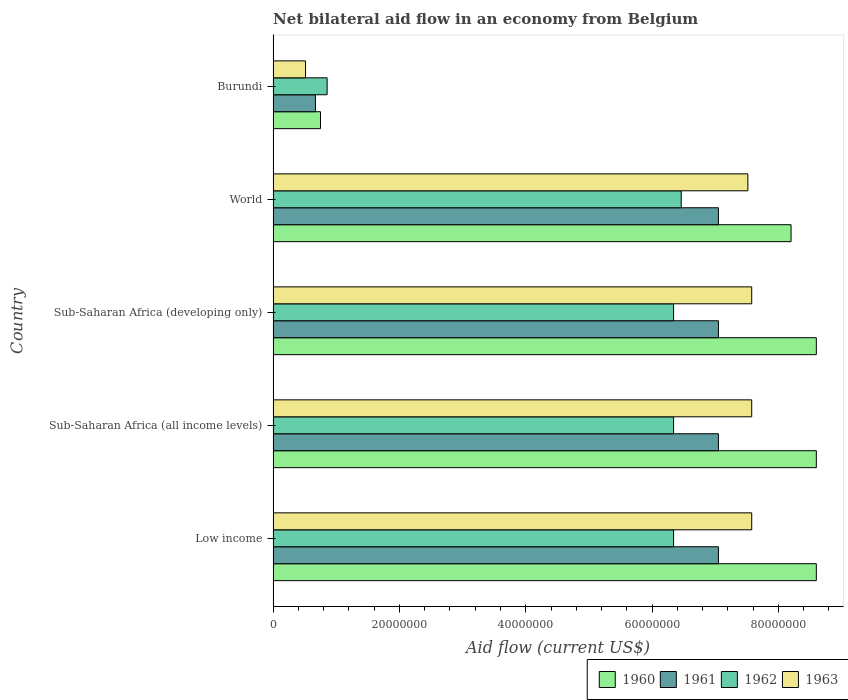How many different coloured bars are there?
Your response must be concise. 4. How many groups of bars are there?
Provide a succinct answer. 5. Are the number of bars per tick equal to the number of legend labels?
Your answer should be compact. Yes. Are the number of bars on each tick of the Y-axis equal?
Offer a very short reply. Yes. In how many cases, is the number of bars for a given country not equal to the number of legend labels?
Make the answer very short. 0. What is the net bilateral aid flow in 1961 in Sub-Saharan Africa (developing only)?
Your answer should be very brief. 7.05e+07. Across all countries, what is the maximum net bilateral aid flow in 1962?
Your response must be concise. 6.46e+07. Across all countries, what is the minimum net bilateral aid flow in 1962?
Your response must be concise. 8.55e+06. In which country was the net bilateral aid flow in 1962 maximum?
Your response must be concise. World. In which country was the net bilateral aid flow in 1962 minimum?
Keep it short and to the point. Burundi. What is the total net bilateral aid flow in 1963 in the graph?
Offer a very short reply. 3.08e+08. What is the difference between the net bilateral aid flow in 1960 in Sub-Saharan Africa (developing only) and that in World?
Your response must be concise. 4.00e+06. What is the difference between the net bilateral aid flow in 1960 in Sub-Saharan Africa (developing only) and the net bilateral aid flow in 1961 in Low income?
Make the answer very short. 1.55e+07. What is the average net bilateral aid flow in 1962 per country?
Provide a succinct answer. 5.27e+07. What is the difference between the net bilateral aid flow in 1962 and net bilateral aid flow in 1960 in Sub-Saharan Africa (developing only)?
Provide a succinct answer. -2.26e+07. In how many countries, is the net bilateral aid flow in 1961 greater than 84000000 US$?
Your answer should be very brief. 0. What is the ratio of the net bilateral aid flow in 1961 in Sub-Saharan Africa (all income levels) to that in World?
Offer a terse response. 1. Is the difference between the net bilateral aid flow in 1962 in Burundi and Low income greater than the difference between the net bilateral aid flow in 1960 in Burundi and Low income?
Give a very brief answer. Yes. What is the difference between the highest and the second highest net bilateral aid flow in 1960?
Your response must be concise. 0. What is the difference between the highest and the lowest net bilateral aid flow in 1963?
Your answer should be compact. 7.06e+07. In how many countries, is the net bilateral aid flow in 1960 greater than the average net bilateral aid flow in 1960 taken over all countries?
Your response must be concise. 4. Is it the case that in every country, the sum of the net bilateral aid flow in 1962 and net bilateral aid flow in 1960 is greater than the sum of net bilateral aid flow in 1961 and net bilateral aid flow in 1963?
Ensure brevity in your answer.  No. What does the 3rd bar from the top in Low income represents?
Your response must be concise. 1961. What does the 1st bar from the bottom in World represents?
Make the answer very short. 1960. How many bars are there?
Your answer should be compact. 20. How many countries are there in the graph?
Your response must be concise. 5. Are the values on the major ticks of X-axis written in scientific E-notation?
Ensure brevity in your answer.  No. Does the graph contain grids?
Ensure brevity in your answer.  No. How many legend labels are there?
Offer a very short reply. 4. How are the legend labels stacked?
Keep it short and to the point. Horizontal. What is the title of the graph?
Offer a very short reply. Net bilateral aid flow in an economy from Belgium. Does "1981" appear as one of the legend labels in the graph?
Your response must be concise. No. What is the Aid flow (current US$) of 1960 in Low income?
Offer a terse response. 8.60e+07. What is the Aid flow (current US$) in 1961 in Low income?
Offer a terse response. 7.05e+07. What is the Aid flow (current US$) of 1962 in Low income?
Offer a very short reply. 6.34e+07. What is the Aid flow (current US$) of 1963 in Low income?
Your response must be concise. 7.58e+07. What is the Aid flow (current US$) in 1960 in Sub-Saharan Africa (all income levels)?
Your answer should be very brief. 8.60e+07. What is the Aid flow (current US$) in 1961 in Sub-Saharan Africa (all income levels)?
Offer a very short reply. 7.05e+07. What is the Aid flow (current US$) in 1962 in Sub-Saharan Africa (all income levels)?
Provide a short and direct response. 6.34e+07. What is the Aid flow (current US$) of 1963 in Sub-Saharan Africa (all income levels)?
Offer a terse response. 7.58e+07. What is the Aid flow (current US$) in 1960 in Sub-Saharan Africa (developing only)?
Provide a succinct answer. 8.60e+07. What is the Aid flow (current US$) of 1961 in Sub-Saharan Africa (developing only)?
Keep it short and to the point. 7.05e+07. What is the Aid flow (current US$) of 1962 in Sub-Saharan Africa (developing only)?
Provide a succinct answer. 6.34e+07. What is the Aid flow (current US$) of 1963 in Sub-Saharan Africa (developing only)?
Make the answer very short. 7.58e+07. What is the Aid flow (current US$) of 1960 in World?
Make the answer very short. 8.20e+07. What is the Aid flow (current US$) in 1961 in World?
Offer a terse response. 7.05e+07. What is the Aid flow (current US$) of 1962 in World?
Your answer should be very brief. 6.46e+07. What is the Aid flow (current US$) in 1963 in World?
Offer a very short reply. 7.52e+07. What is the Aid flow (current US$) in 1960 in Burundi?
Provide a short and direct response. 7.50e+06. What is the Aid flow (current US$) in 1961 in Burundi?
Your response must be concise. 6.70e+06. What is the Aid flow (current US$) of 1962 in Burundi?
Offer a terse response. 8.55e+06. What is the Aid flow (current US$) in 1963 in Burundi?
Offer a very short reply. 5.13e+06. Across all countries, what is the maximum Aid flow (current US$) of 1960?
Provide a succinct answer. 8.60e+07. Across all countries, what is the maximum Aid flow (current US$) in 1961?
Your answer should be compact. 7.05e+07. Across all countries, what is the maximum Aid flow (current US$) of 1962?
Ensure brevity in your answer.  6.46e+07. Across all countries, what is the maximum Aid flow (current US$) in 1963?
Provide a succinct answer. 7.58e+07. Across all countries, what is the minimum Aid flow (current US$) of 1960?
Offer a very short reply. 7.50e+06. Across all countries, what is the minimum Aid flow (current US$) in 1961?
Keep it short and to the point. 6.70e+06. Across all countries, what is the minimum Aid flow (current US$) in 1962?
Provide a succinct answer. 8.55e+06. Across all countries, what is the minimum Aid flow (current US$) of 1963?
Give a very brief answer. 5.13e+06. What is the total Aid flow (current US$) of 1960 in the graph?
Offer a very short reply. 3.48e+08. What is the total Aid flow (current US$) in 1961 in the graph?
Provide a succinct answer. 2.89e+08. What is the total Aid flow (current US$) of 1962 in the graph?
Give a very brief answer. 2.63e+08. What is the total Aid flow (current US$) in 1963 in the graph?
Provide a succinct answer. 3.08e+08. What is the difference between the Aid flow (current US$) of 1961 in Low income and that in Sub-Saharan Africa (developing only)?
Offer a very short reply. 0. What is the difference between the Aid flow (current US$) of 1960 in Low income and that in World?
Offer a very short reply. 4.00e+06. What is the difference between the Aid flow (current US$) in 1962 in Low income and that in World?
Make the answer very short. -1.21e+06. What is the difference between the Aid flow (current US$) of 1963 in Low income and that in World?
Ensure brevity in your answer.  6.10e+05. What is the difference between the Aid flow (current US$) in 1960 in Low income and that in Burundi?
Keep it short and to the point. 7.85e+07. What is the difference between the Aid flow (current US$) of 1961 in Low income and that in Burundi?
Your answer should be very brief. 6.38e+07. What is the difference between the Aid flow (current US$) of 1962 in Low income and that in Burundi?
Offer a terse response. 5.48e+07. What is the difference between the Aid flow (current US$) in 1963 in Low income and that in Burundi?
Ensure brevity in your answer.  7.06e+07. What is the difference between the Aid flow (current US$) in 1961 in Sub-Saharan Africa (all income levels) and that in Sub-Saharan Africa (developing only)?
Make the answer very short. 0. What is the difference between the Aid flow (current US$) in 1962 in Sub-Saharan Africa (all income levels) and that in Sub-Saharan Africa (developing only)?
Provide a short and direct response. 0. What is the difference between the Aid flow (current US$) of 1963 in Sub-Saharan Africa (all income levels) and that in Sub-Saharan Africa (developing only)?
Make the answer very short. 0. What is the difference between the Aid flow (current US$) of 1960 in Sub-Saharan Africa (all income levels) and that in World?
Provide a short and direct response. 4.00e+06. What is the difference between the Aid flow (current US$) of 1961 in Sub-Saharan Africa (all income levels) and that in World?
Give a very brief answer. 0. What is the difference between the Aid flow (current US$) of 1962 in Sub-Saharan Africa (all income levels) and that in World?
Give a very brief answer. -1.21e+06. What is the difference between the Aid flow (current US$) in 1963 in Sub-Saharan Africa (all income levels) and that in World?
Offer a very short reply. 6.10e+05. What is the difference between the Aid flow (current US$) of 1960 in Sub-Saharan Africa (all income levels) and that in Burundi?
Your answer should be compact. 7.85e+07. What is the difference between the Aid flow (current US$) of 1961 in Sub-Saharan Africa (all income levels) and that in Burundi?
Offer a terse response. 6.38e+07. What is the difference between the Aid flow (current US$) in 1962 in Sub-Saharan Africa (all income levels) and that in Burundi?
Provide a short and direct response. 5.48e+07. What is the difference between the Aid flow (current US$) of 1963 in Sub-Saharan Africa (all income levels) and that in Burundi?
Give a very brief answer. 7.06e+07. What is the difference between the Aid flow (current US$) of 1962 in Sub-Saharan Africa (developing only) and that in World?
Provide a succinct answer. -1.21e+06. What is the difference between the Aid flow (current US$) in 1960 in Sub-Saharan Africa (developing only) and that in Burundi?
Make the answer very short. 7.85e+07. What is the difference between the Aid flow (current US$) of 1961 in Sub-Saharan Africa (developing only) and that in Burundi?
Ensure brevity in your answer.  6.38e+07. What is the difference between the Aid flow (current US$) of 1962 in Sub-Saharan Africa (developing only) and that in Burundi?
Ensure brevity in your answer.  5.48e+07. What is the difference between the Aid flow (current US$) in 1963 in Sub-Saharan Africa (developing only) and that in Burundi?
Give a very brief answer. 7.06e+07. What is the difference between the Aid flow (current US$) of 1960 in World and that in Burundi?
Offer a terse response. 7.45e+07. What is the difference between the Aid flow (current US$) of 1961 in World and that in Burundi?
Keep it short and to the point. 6.38e+07. What is the difference between the Aid flow (current US$) in 1962 in World and that in Burundi?
Keep it short and to the point. 5.61e+07. What is the difference between the Aid flow (current US$) in 1963 in World and that in Burundi?
Your answer should be compact. 7.00e+07. What is the difference between the Aid flow (current US$) in 1960 in Low income and the Aid flow (current US$) in 1961 in Sub-Saharan Africa (all income levels)?
Provide a short and direct response. 1.55e+07. What is the difference between the Aid flow (current US$) of 1960 in Low income and the Aid flow (current US$) of 1962 in Sub-Saharan Africa (all income levels)?
Offer a very short reply. 2.26e+07. What is the difference between the Aid flow (current US$) of 1960 in Low income and the Aid flow (current US$) of 1963 in Sub-Saharan Africa (all income levels)?
Provide a short and direct response. 1.02e+07. What is the difference between the Aid flow (current US$) in 1961 in Low income and the Aid flow (current US$) in 1962 in Sub-Saharan Africa (all income levels)?
Make the answer very short. 7.10e+06. What is the difference between the Aid flow (current US$) in 1961 in Low income and the Aid flow (current US$) in 1963 in Sub-Saharan Africa (all income levels)?
Offer a terse response. -5.27e+06. What is the difference between the Aid flow (current US$) in 1962 in Low income and the Aid flow (current US$) in 1963 in Sub-Saharan Africa (all income levels)?
Keep it short and to the point. -1.24e+07. What is the difference between the Aid flow (current US$) in 1960 in Low income and the Aid flow (current US$) in 1961 in Sub-Saharan Africa (developing only)?
Give a very brief answer. 1.55e+07. What is the difference between the Aid flow (current US$) in 1960 in Low income and the Aid flow (current US$) in 1962 in Sub-Saharan Africa (developing only)?
Keep it short and to the point. 2.26e+07. What is the difference between the Aid flow (current US$) of 1960 in Low income and the Aid flow (current US$) of 1963 in Sub-Saharan Africa (developing only)?
Offer a terse response. 1.02e+07. What is the difference between the Aid flow (current US$) of 1961 in Low income and the Aid flow (current US$) of 1962 in Sub-Saharan Africa (developing only)?
Offer a terse response. 7.10e+06. What is the difference between the Aid flow (current US$) of 1961 in Low income and the Aid flow (current US$) of 1963 in Sub-Saharan Africa (developing only)?
Keep it short and to the point. -5.27e+06. What is the difference between the Aid flow (current US$) of 1962 in Low income and the Aid flow (current US$) of 1963 in Sub-Saharan Africa (developing only)?
Keep it short and to the point. -1.24e+07. What is the difference between the Aid flow (current US$) in 1960 in Low income and the Aid flow (current US$) in 1961 in World?
Make the answer very short. 1.55e+07. What is the difference between the Aid flow (current US$) of 1960 in Low income and the Aid flow (current US$) of 1962 in World?
Make the answer very short. 2.14e+07. What is the difference between the Aid flow (current US$) of 1960 in Low income and the Aid flow (current US$) of 1963 in World?
Your response must be concise. 1.08e+07. What is the difference between the Aid flow (current US$) in 1961 in Low income and the Aid flow (current US$) in 1962 in World?
Keep it short and to the point. 5.89e+06. What is the difference between the Aid flow (current US$) of 1961 in Low income and the Aid flow (current US$) of 1963 in World?
Keep it short and to the point. -4.66e+06. What is the difference between the Aid flow (current US$) of 1962 in Low income and the Aid flow (current US$) of 1963 in World?
Ensure brevity in your answer.  -1.18e+07. What is the difference between the Aid flow (current US$) in 1960 in Low income and the Aid flow (current US$) in 1961 in Burundi?
Make the answer very short. 7.93e+07. What is the difference between the Aid flow (current US$) in 1960 in Low income and the Aid flow (current US$) in 1962 in Burundi?
Offer a very short reply. 7.74e+07. What is the difference between the Aid flow (current US$) of 1960 in Low income and the Aid flow (current US$) of 1963 in Burundi?
Your answer should be very brief. 8.09e+07. What is the difference between the Aid flow (current US$) in 1961 in Low income and the Aid flow (current US$) in 1962 in Burundi?
Offer a terse response. 6.20e+07. What is the difference between the Aid flow (current US$) in 1961 in Low income and the Aid flow (current US$) in 1963 in Burundi?
Offer a terse response. 6.54e+07. What is the difference between the Aid flow (current US$) of 1962 in Low income and the Aid flow (current US$) of 1963 in Burundi?
Offer a terse response. 5.83e+07. What is the difference between the Aid flow (current US$) in 1960 in Sub-Saharan Africa (all income levels) and the Aid flow (current US$) in 1961 in Sub-Saharan Africa (developing only)?
Your answer should be compact. 1.55e+07. What is the difference between the Aid flow (current US$) in 1960 in Sub-Saharan Africa (all income levels) and the Aid flow (current US$) in 1962 in Sub-Saharan Africa (developing only)?
Make the answer very short. 2.26e+07. What is the difference between the Aid flow (current US$) in 1960 in Sub-Saharan Africa (all income levels) and the Aid flow (current US$) in 1963 in Sub-Saharan Africa (developing only)?
Your response must be concise. 1.02e+07. What is the difference between the Aid flow (current US$) of 1961 in Sub-Saharan Africa (all income levels) and the Aid flow (current US$) of 1962 in Sub-Saharan Africa (developing only)?
Provide a succinct answer. 7.10e+06. What is the difference between the Aid flow (current US$) in 1961 in Sub-Saharan Africa (all income levels) and the Aid flow (current US$) in 1963 in Sub-Saharan Africa (developing only)?
Your response must be concise. -5.27e+06. What is the difference between the Aid flow (current US$) of 1962 in Sub-Saharan Africa (all income levels) and the Aid flow (current US$) of 1963 in Sub-Saharan Africa (developing only)?
Keep it short and to the point. -1.24e+07. What is the difference between the Aid flow (current US$) of 1960 in Sub-Saharan Africa (all income levels) and the Aid flow (current US$) of 1961 in World?
Your response must be concise. 1.55e+07. What is the difference between the Aid flow (current US$) of 1960 in Sub-Saharan Africa (all income levels) and the Aid flow (current US$) of 1962 in World?
Provide a short and direct response. 2.14e+07. What is the difference between the Aid flow (current US$) of 1960 in Sub-Saharan Africa (all income levels) and the Aid flow (current US$) of 1963 in World?
Provide a succinct answer. 1.08e+07. What is the difference between the Aid flow (current US$) of 1961 in Sub-Saharan Africa (all income levels) and the Aid flow (current US$) of 1962 in World?
Provide a short and direct response. 5.89e+06. What is the difference between the Aid flow (current US$) in 1961 in Sub-Saharan Africa (all income levels) and the Aid flow (current US$) in 1963 in World?
Keep it short and to the point. -4.66e+06. What is the difference between the Aid flow (current US$) of 1962 in Sub-Saharan Africa (all income levels) and the Aid flow (current US$) of 1963 in World?
Provide a short and direct response. -1.18e+07. What is the difference between the Aid flow (current US$) in 1960 in Sub-Saharan Africa (all income levels) and the Aid flow (current US$) in 1961 in Burundi?
Make the answer very short. 7.93e+07. What is the difference between the Aid flow (current US$) in 1960 in Sub-Saharan Africa (all income levels) and the Aid flow (current US$) in 1962 in Burundi?
Provide a short and direct response. 7.74e+07. What is the difference between the Aid flow (current US$) in 1960 in Sub-Saharan Africa (all income levels) and the Aid flow (current US$) in 1963 in Burundi?
Your response must be concise. 8.09e+07. What is the difference between the Aid flow (current US$) of 1961 in Sub-Saharan Africa (all income levels) and the Aid flow (current US$) of 1962 in Burundi?
Give a very brief answer. 6.20e+07. What is the difference between the Aid flow (current US$) of 1961 in Sub-Saharan Africa (all income levels) and the Aid flow (current US$) of 1963 in Burundi?
Offer a very short reply. 6.54e+07. What is the difference between the Aid flow (current US$) of 1962 in Sub-Saharan Africa (all income levels) and the Aid flow (current US$) of 1963 in Burundi?
Offer a terse response. 5.83e+07. What is the difference between the Aid flow (current US$) in 1960 in Sub-Saharan Africa (developing only) and the Aid flow (current US$) in 1961 in World?
Your answer should be compact. 1.55e+07. What is the difference between the Aid flow (current US$) in 1960 in Sub-Saharan Africa (developing only) and the Aid flow (current US$) in 1962 in World?
Offer a very short reply. 2.14e+07. What is the difference between the Aid flow (current US$) of 1960 in Sub-Saharan Africa (developing only) and the Aid flow (current US$) of 1963 in World?
Your response must be concise. 1.08e+07. What is the difference between the Aid flow (current US$) in 1961 in Sub-Saharan Africa (developing only) and the Aid flow (current US$) in 1962 in World?
Provide a succinct answer. 5.89e+06. What is the difference between the Aid flow (current US$) of 1961 in Sub-Saharan Africa (developing only) and the Aid flow (current US$) of 1963 in World?
Provide a short and direct response. -4.66e+06. What is the difference between the Aid flow (current US$) in 1962 in Sub-Saharan Africa (developing only) and the Aid flow (current US$) in 1963 in World?
Give a very brief answer. -1.18e+07. What is the difference between the Aid flow (current US$) in 1960 in Sub-Saharan Africa (developing only) and the Aid flow (current US$) in 1961 in Burundi?
Your response must be concise. 7.93e+07. What is the difference between the Aid flow (current US$) of 1960 in Sub-Saharan Africa (developing only) and the Aid flow (current US$) of 1962 in Burundi?
Provide a succinct answer. 7.74e+07. What is the difference between the Aid flow (current US$) in 1960 in Sub-Saharan Africa (developing only) and the Aid flow (current US$) in 1963 in Burundi?
Your answer should be compact. 8.09e+07. What is the difference between the Aid flow (current US$) in 1961 in Sub-Saharan Africa (developing only) and the Aid flow (current US$) in 1962 in Burundi?
Your answer should be very brief. 6.20e+07. What is the difference between the Aid flow (current US$) in 1961 in Sub-Saharan Africa (developing only) and the Aid flow (current US$) in 1963 in Burundi?
Ensure brevity in your answer.  6.54e+07. What is the difference between the Aid flow (current US$) in 1962 in Sub-Saharan Africa (developing only) and the Aid flow (current US$) in 1963 in Burundi?
Your answer should be compact. 5.83e+07. What is the difference between the Aid flow (current US$) of 1960 in World and the Aid flow (current US$) of 1961 in Burundi?
Provide a succinct answer. 7.53e+07. What is the difference between the Aid flow (current US$) in 1960 in World and the Aid flow (current US$) in 1962 in Burundi?
Keep it short and to the point. 7.34e+07. What is the difference between the Aid flow (current US$) of 1960 in World and the Aid flow (current US$) of 1963 in Burundi?
Make the answer very short. 7.69e+07. What is the difference between the Aid flow (current US$) in 1961 in World and the Aid flow (current US$) in 1962 in Burundi?
Ensure brevity in your answer.  6.20e+07. What is the difference between the Aid flow (current US$) in 1961 in World and the Aid flow (current US$) in 1963 in Burundi?
Offer a very short reply. 6.54e+07. What is the difference between the Aid flow (current US$) of 1962 in World and the Aid flow (current US$) of 1963 in Burundi?
Ensure brevity in your answer.  5.95e+07. What is the average Aid flow (current US$) in 1960 per country?
Your answer should be very brief. 6.95e+07. What is the average Aid flow (current US$) of 1961 per country?
Keep it short and to the point. 5.77e+07. What is the average Aid flow (current US$) of 1962 per country?
Provide a short and direct response. 5.27e+07. What is the average Aid flow (current US$) in 1963 per country?
Provide a succinct answer. 6.15e+07. What is the difference between the Aid flow (current US$) of 1960 and Aid flow (current US$) of 1961 in Low income?
Keep it short and to the point. 1.55e+07. What is the difference between the Aid flow (current US$) of 1960 and Aid flow (current US$) of 1962 in Low income?
Your answer should be compact. 2.26e+07. What is the difference between the Aid flow (current US$) in 1960 and Aid flow (current US$) in 1963 in Low income?
Ensure brevity in your answer.  1.02e+07. What is the difference between the Aid flow (current US$) of 1961 and Aid flow (current US$) of 1962 in Low income?
Provide a short and direct response. 7.10e+06. What is the difference between the Aid flow (current US$) of 1961 and Aid flow (current US$) of 1963 in Low income?
Give a very brief answer. -5.27e+06. What is the difference between the Aid flow (current US$) in 1962 and Aid flow (current US$) in 1963 in Low income?
Offer a terse response. -1.24e+07. What is the difference between the Aid flow (current US$) of 1960 and Aid flow (current US$) of 1961 in Sub-Saharan Africa (all income levels)?
Give a very brief answer. 1.55e+07. What is the difference between the Aid flow (current US$) of 1960 and Aid flow (current US$) of 1962 in Sub-Saharan Africa (all income levels)?
Your response must be concise. 2.26e+07. What is the difference between the Aid flow (current US$) of 1960 and Aid flow (current US$) of 1963 in Sub-Saharan Africa (all income levels)?
Ensure brevity in your answer.  1.02e+07. What is the difference between the Aid flow (current US$) in 1961 and Aid flow (current US$) in 1962 in Sub-Saharan Africa (all income levels)?
Your answer should be compact. 7.10e+06. What is the difference between the Aid flow (current US$) of 1961 and Aid flow (current US$) of 1963 in Sub-Saharan Africa (all income levels)?
Make the answer very short. -5.27e+06. What is the difference between the Aid flow (current US$) in 1962 and Aid flow (current US$) in 1963 in Sub-Saharan Africa (all income levels)?
Give a very brief answer. -1.24e+07. What is the difference between the Aid flow (current US$) of 1960 and Aid flow (current US$) of 1961 in Sub-Saharan Africa (developing only)?
Ensure brevity in your answer.  1.55e+07. What is the difference between the Aid flow (current US$) of 1960 and Aid flow (current US$) of 1962 in Sub-Saharan Africa (developing only)?
Offer a very short reply. 2.26e+07. What is the difference between the Aid flow (current US$) in 1960 and Aid flow (current US$) in 1963 in Sub-Saharan Africa (developing only)?
Provide a succinct answer. 1.02e+07. What is the difference between the Aid flow (current US$) of 1961 and Aid flow (current US$) of 1962 in Sub-Saharan Africa (developing only)?
Offer a very short reply. 7.10e+06. What is the difference between the Aid flow (current US$) of 1961 and Aid flow (current US$) of 1963 in Sub-Saharan Africa (developing only)?
Provide a succinct answer. -5.27e+06. What is the difference between the Aid flow (current US$) of 1962 and Aid flow (current US$) of 1963 in Sub-Saharan Africa (developing only)?
Provide a short and direct response. -1.24e+07. What is the difference between the Aid flow (current US$) in 1960 and Aid flow (current US$) in 1961 in World?
Your response must be concise. 1.15e+07. What is the difference between the Aid flow (current US$) of 1960 and Aid flow (current US$) of 1962 in World?
Offer a very short reply. 1.74e+07. What is the difference between the Aid flow (current US$) in 1960 and Aid flow (current US$) in 1963 in World?
Your response must be concise. 6.84e+06. What is the difference between the Aid flow (current US$) of 1961 and Aid flow (current US$) of 1962 in World?
Your answer should be very brief. 5.89e+06. What is the difference between the Aid flow (current US$) in 1961 and Aid flow (current US$) in 1963 in World?
Your response must be concise. -4.66e+06. What is the difference between the Aid flow (current US$) of 1962 and Aid flow (current US$) of 1963 in World?
Make the answer very short. -1.06e+07. What is the difference between the Aid flow (current US$) of 1960 and Aid flow (current US$) of 1961 in Burundi?
Provide a succinct answer. 8.00e+05. What is the difference between the Aid flow (current US$) in 1960 and Aid flow (current US$) in 1962 in Burundi?
Provide a short and direct response. -1.05e+06. What is the difference between the Aid flow (current US$) in 1960 and Aid flow (current US$) in 1963 in Burundi?
Keep it short and to the point. 2.37e+06. What is the difference between the Aid flow (current US$) of 1961 and Aid flow (current US$) of 1962 in Burundi?
Offer a very short reply. -1.85e+06. What is the difference between the Aid flow (current US$) in 1961 and Aid flow (current US$) in 1963 in Burundi?
Your answer should be very brief. 1.57e+06. What is the difference between the Aid flow (current US$) in 1962 and Aid flow (current US$) in 1963 in Burundi?
Your answer should be very brief. 3.42e+06. What is the ratio of the Aid flow (current US$) of 1960 in Low income to that in Sub-Saharan Africa (all income levels)?
Offer a very short reply. 1. What is the ratio of the Aid flow (current US$) in 1963 in Low income to that in Sub-Saharan Africa (all income levels)?
Provide a succinct answer. 1. What is the ratio of the Aid flow (current US$) in 1960 in Low income to that in Sub-Saharan Africa (developing only)?
Offer a terse response. 1. What is the ratio of the Aid flow (current US$) of 1960 in Low income to that in World?
Keep it short and to the point. 1.05. What is the ratio of the Aid flow (current US$) in 1961 in Low income to that in World?
Offer a very short reply. 1. What is the ratio of the Aid flow (current US$) of 1962 in Low income to that in World?
Provide a succinct answer. 0.98. What is the ratio of the Aid flow (current US$) of 1960 in Low income to that in Burundi?
Your answer should be compact. 11.47. What is the ratio of the Aid flow (current US$) of 1961 in Low income to that in Burundi?
Offer a very short reply. 10.52. What is the ratio of the Aid flow (current US$) in 1962 in Low income to that in Burundi?
Provide a succinct answer. 7.42. What is the ratio of the Aid flow (current US$) in 1963 in Low income to that in Burundi?
Give a very brief answer. 14.77. What is the ratio of the Aid flow (current US$) of 1962 in Sub-Saharan Africa (all income levels) to that in Sub-Saharan Africa (developing only)?
Your response must be concise. 1. What is the ratio of the Aid flow (current US$) in 1960 in Sub-Saharan Africa (all income levels) to that in World?
Offer a very short reply. 1.05. What is the ratio of the Aid flow (current US$) in 1961 in Sub-Saharan Africa (all income levels) to that in World?
Your response must be concise. 1. What is the ratio of the Aid flow (current US$) in 1962 in Sub-Saharan Africa (all income levels) to that in World?
Make the answer very short. 0.98. What is the ratio of the Aid flow (current US$) in 1960 in Sub-Saharan Africa (all income levels) to that in Burundi?
Keep it short and to the point. 11.47. What is the ratio of the Aid flow (current US$) in 1961 in Sub-Saharan Africa (all income levels) to that in Burundi?
Your response must be concise. 10.52. What is the ratio of the Aid flow (current US$) of 1962 in Sub-Saharan Africa (all income levels) to that in Burundi?
Provide a succinct answer. 7.42. What is the ratio of the Aid flow (current US$) of 1963 in Sub-Saharan Africa (all income levels) to that in Burundi?
Keep it short and to the point. 14.77. What is the ratio of the Aid flow (current US$) of 1960 in Sub-Saharan Africa (developing only) to that in World?
Make the answer very short. 1.05. What is the ratio of the Aid flow (current US$) in 1961 in Sub-Saharan Africa (developing only) to that in World?
Provide a succinct answer. 1. What is the ratio of the Aid flow (current US$) of 1962 in Sub-Saharan Africa (developing only) to that in World?
Offer a terse response. 0.98. What is the ratio of the Aid flow (current US$) in 1960 in Sub-Saharan Africa (developing only) to that in Burundi?
Make the answer very short. 11.47. What is the ratio of the Aid flow (current US$) of 1961 in Sub-Saharan Africa (developing only) to that in Burundi?
Provide a succinct answer. 10.52. What is the ratio of the Aid flow (current US$) in 1962 in Sub-Saharan Africa (developing only) to that in Burundi?
Make the answer very short. 7.42. What is the ratio of the Aid flow (current US$) of 1963 in Sub-Saharan Africa (developing only) to that in Burundi?
Provide a short and direct response. 14.77. What is the ratio of the Aid flow (current US$) in 1960 in World to that in Burundi?
Keep it short and to the point. 10.93. What is the ratio of the Aid flow (current US$) of 1961 in World to that in Burundi?
Keep it short and to the point. 10.52. What is the ratio of the Aid flow (current US$) in 1962 in World to that in Burundi?
Your response must be concise. 7.56. What is the ratio of the Aid flow (current US$) of 1963 in World to that in Burundi?
Make the answer very short. 14.65. What is the difference between the highest and the second highest Aid flow (current US$) of 1961?
Make the answer very short. 0. What is the difference between the highest and the second highest Aid flow (current US$) of 1962?
Offer a very short reply. 1.21e+06. What is the difference between the highest and the lowest Aid flow (current US$) of 1960?
Offer a very short reply. 7.85e+07. What is the difference between the highest and the lowest Aid flow (current US$) in 1961?
Your answer should be compact. 6.38e+07. What is the difference between the highest and the lowest Aid flow (current US$) in 1962?
Your response must be concise. 5.61e+07. What is the difference between the highest and the lowest Aid flow (current US$) of 1963?
Your response must be concise. 7.06e+07. 